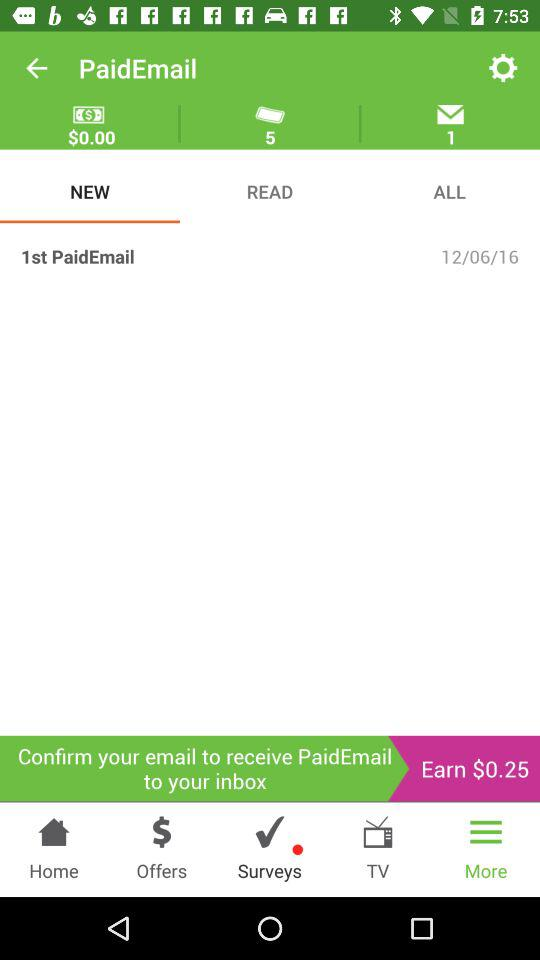What is the selected tab? The selected tabs are "NEW" and "More". 